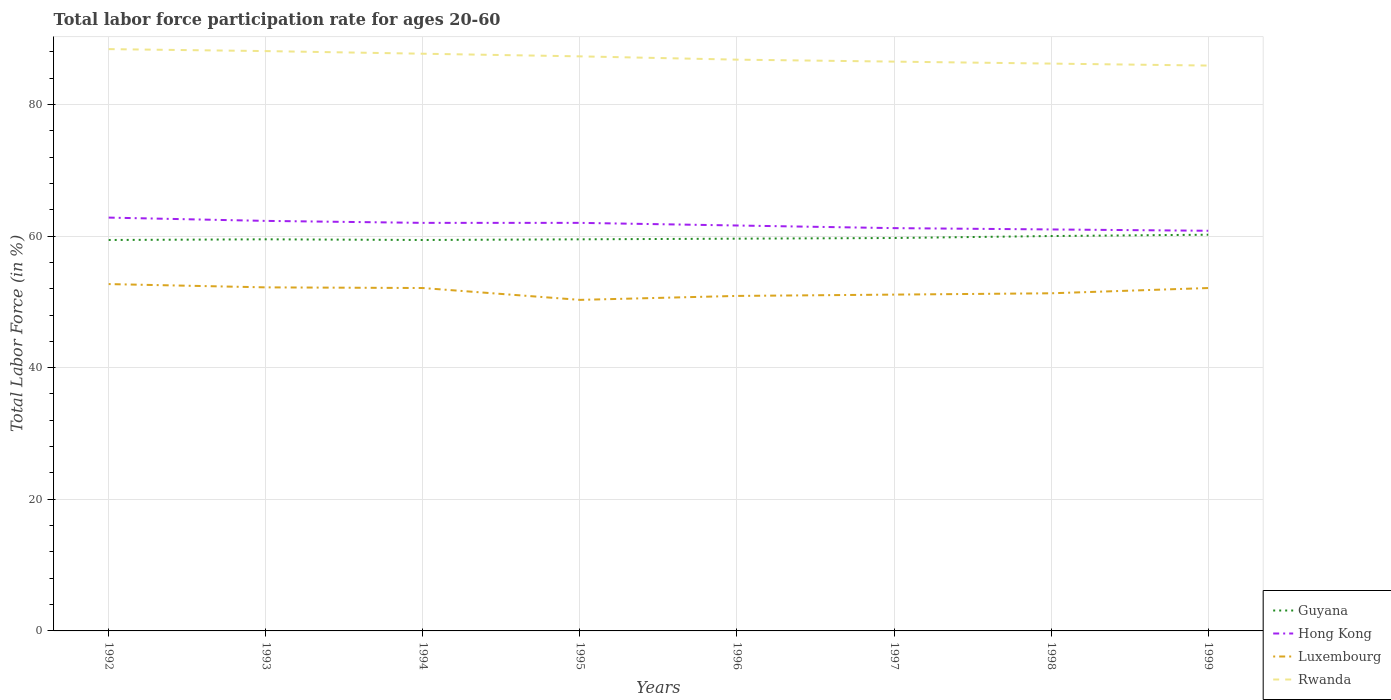How many different coloured lines are there?
Your answer should be very brief. 4. Does the line corresponding to Rwanda intersect with the line corresponding to Luxembourg?
Your response must be concise. No. Is the number of lines equal to the number of legend labels?
Give a very brief answer. Yes. Across all years, what is the maximum labor force participation rate in Luxembourg?
Offer a terse response. 50.3. In which year was the labor force participation rate in Luxembourg maximum?
Your answer should be compact. 1995. What is the total labor force participation rate in Luxembourg in the graph?
Offer a terse response. -0.2. What is the difference between the highest and the second highest labor force participation rate in Luxembourg?
Offer a terse response. 2.4. What is the difference between the highest and the lowest labor force participation rate in Luxembourg?
Ensure brevity in your answer.  4. What is the difference between two consecutive major ticks on the Y-axis?
Provide a short and direct response. 20. Does the graph contain any zero values?
Your response must be concise. No. Where does the legend appear in the graph?
Give a very brief answer. Bottom right. How many legend labels are there?
Your answer should be very brief. 4. How are the legend labels stacked?
Provide a short and direct response. Vertical. What is the title of the graph?
Provide a succinct answer. Total labor force participation rate for ages 20-60. Does "Poland" appear as one of the legend labels in the graph?
Give a very brief answer. No. What is the label or title of the X-axis?
Your response must be concise. Years. What is the Total Labor Force (in %) in Guyana in 1992?
Give a very brief answer. 59.4. What is the Total Labor Force (in %) of Hong Kong in 1992?
Provide a succinct answer. 62.8. What is the Total Labor Force (in %) in Luxembourg in 1992?
Your answer should be compact. 52.7. What is the Total Labor Force (in %) in Rwanda in 1992?
Offer a terse response. 88.4. What is the Total Labor Force (in %) in Guyana in 1993?
Keep it short and to the point. 59.5. What is the Total Labor Force (in %) in Hong Kong in 1993?
Make the answer very short. 62.3. What is the Total Labor Force (in %) in Luxembourg in 1993?
Ensure brevity in your answer.  52.2. What is the Total Labor Force (in %) of Rwanda in 1993?
Ensure brevity in your answer.  88.1. What is the Total Labor Force (in %) in Guyana in 1994?
Make the answer very short. 59.4. What is the Total Labor Force (in %) of Luxembourg in 1994?
Your answer should be compact. 52.1. What is the Total Labor Force (in %) of Rwanda in 1994?
Your answer should be very brief. 87.7. What is the Total Labor Force (in %) of Guyana in 1995?
Ensure brevity in your answer.  59.5. What is the Total Labor Force (in %) in Luxembourg in 1995?
Your answer should be very brief. 50.3. What is the Total Labor Force (in %) of Rwanda in 1995?
Offer a very short reply. 87.3. What is the Total Labor Force (in %) of Guyana in 1996?
Offer a very short reply. 59.6. What is the Total Labor Force (in %) of Hong Kong in 1996?
Offer a terse response. 61.6. What is the Total Labor Force (in %) of Luxembourg in 1996?
Ensure brevity in your answer.  50.9. What is the Total Labor Force (in %) in Rwanda in 1996?
Offer a terse response. 86.8. What is the Total Labor Force (in %) in Guyana in 1997?
Make the answer very short. 59.7. What is the Total Labor Force (in %) in Hong Kong in 1997?
Provide a succinct answer. 61.2. What is the Total Labor Force (in %) in Luxembourg in 1997?
Your answer should be compact. 51.1. What is the Total Labor Force (in %) of Rwanda in 1997?
Ensure brevity in your answer.  86.5. What is the Total Labor Force (in %) in Guyana in 1998?
Your answer should be compact. 60. What is the Total Labor Force (in %) in Luxembourg in 1998?
Provide a succinct answer. 51.3. What is the Total Labor Force (in %) of Rwanda in 1998?
Keep it short and to the point. 86.2. What is the Total Labor Force (in %) in Guyana in 1999?
Provide a short and direct response. 60.2. What is the Total Labor Force (in %) of Hong Kong in 1999?
Keep it short and to the point. 60.8. What is the Total Labor Force (in %) of Luxembourg in 1999?
Your response must be concise. 52.1. What is the Total Labor Force (in %) in Rwanda in 1999?
Give a very brief answer. 85.9. Across all years, what is the maximum Total Labor Force (in %) of Guyana?
Keep it short and to the point. 60.2. Across all years, what is the maximum Total Labor Force (in %) of Hong Kong?
Make the answer very short. 62.8. Across all years, what is the maximum Total Labor Force (in %) in Luxembourg?
Keep it short and to the point. 52.7. Across all years, what is the maximum Total Labor Force (in %) of Rwanda?
Your response must be concise. 88.4. Across all years, what is the minimum Total Labor Force (in %) of Guyana?
Your answer should be compact. 59.4. Across all years, what is the minimum Total Labor Force (in %) of Hong Kong?
Keep it short and to the point. 60.8. Across all years, what is the minimum Total Labor Force (in %) of Luxembourg?
Offer a very short reply. 50.3. Across all years, what is the minimum Total Labor Force (in %) of Rwanda?
Keep it short and to the point. 85.9. What is the total Total Labor Force (in %) of Guyana in the graph?
Offer a very short reply. 477.3. What is the total Total Labor Force (in %) of Hong Kong in the graph?
Give a very brief answer. 493.7. What is the total Total Labor Force (in %) of Luxembourg in the graph?
Offer a very short reply. 412.7. What is the total Total Labor Force (in %) of Rwanda in the graph?
Offer a very short reply. 696.9. What is the difference between the Total Labor Force (in %) in Guyana in 1992 and that in 1993?
Make the answer very short. -0.1. What is the difference between the Total Labor Force (in %) in Hong Kong in 1992 and that in 1993?
Ensure brevity in your answer.  0.5. What is the difference between the Total Labor Force (in %) of Guyana in 1992 and that in 1994?
Your response must be concise. 0. What is the difference between the Total Labor Force (in %) of Luxembourg in 1992 and that in 1994?
Offer a very short reply. 0.6. What is the difference between the Total Labor Force (in %) in Rwanda in 1992 and that in 1994?
Provide a succinct answer. 0.7. What is the difference between the Total Labor Force (in %) in Guyana in 1992 and that in 1995?
Provide a short and direct response. -0.1. What is the difference between the Total Labor Force (in %) of Hong Kong in 1992 and that in 1995?
Keep it short and to the point. 0.8. What is the difference between the Total Labor Force (in %) of Luxembourg in 1992 and that in 1995?
Provide a succinct answer. 2.4. What is the difference between the Total Labor Force (in %) in Luxembourg in 1992 and that in 1996?
Make the answer very short. 1.8. What is the difference between the Total Labor Force (in %) in Hong Kong in 1992 and that in 1997?
Make the answer very short. 1.6. What is the difference between the Total Labor Force (in %) of Luxembourg in 1992 and that in 1997?
Your answer should be very brief. 1.6. What is the difference between the Total Labor Force (in %) in Rwanda in 1992 and that in 1997?
Provide a short and direct response. 1.9. What is the difference between the Total Labor Force (in %) in Guyana in 1992 and that in 1998?
Give a very brief answer. -0.6. What is the difference between the Total Labor Force (in %) in Hong Kong in 1992 and that in 1998?
Provide a short and direct response. 1.8. What is the difference between the Total Labor Force (in %) in Luxembourg in 1992 and that in 1998?
Provide a succinct answer. 1.4. What is the difference between the Total Labor Force (in %) of Guyana in 1992 and that in 1999?
Provide a short and direct response. -0.8. What is the difference between the Total Labor Force (in %) of Luxembourg in 1992 and that in 1999?
Give a very brief answer. 0.6. What is the difference between the Total Labor Force (in %) in Luxembourg in 1993 and that in 1994?
Keep it short and to the point. 0.1. What is the difference between the Total Labor Force (in %) in Luxembourg in 1993 and that in 1995?
Provide a succinct answer. 1.9. What is the difference between the Total Labor Force (in %) in Luxembourg in 1993 and that in 1996?
Your answer should be very brief. 1.3. What is the difference between the Total Labor Force (in %) in Rwanda in 1993 and that in 1996?
Offer a very short reply. 1.3. What is the difference between the Total Labor Force (in %) of Guyana in 1993 and that in 1997?
Make the answer very short. -0.2. What is the difference between the Total Labor Force (in %) of Luxembourg in 1993 and that in 1997?
Your response must be concise. 1.1. What is the difference between the Total Labor Force (in %) in Rwanda in 1993 and that in 1997?
Offer a very short reply. 1.6. What is the difference between the Total Labor Force (in %) in Rwanda in 1993 and that in 1998?
Provide a succinct answer. 1.9. What is the difference between the Total Labor Force (in %) in Guyana in 1993 and that in 1999?
Provide a short and direct response. -0.7. What is the difference between the Total Labor Force (in %) of Luxembourg in 1993 and that in 1999?
Make the answer very short. 0.1. What is the difference between the Total Labor Force (in %) of Guyana in 1994 and that in 1995?
Offer a very short reply. -0.1. What is the difference between the Total Labor Force (in %) of Hong Kong in 1994 and that in 1995?
Ensure brevity in your answer.  0. What is the difference between the Total Labor Force (in %) in Luxembourg in 1994 and that in 1995?
Keep it short and to the point. 1.8. What is the difference between the Total Labor Force (in %) of Rwanda in 1994 and that in 1995?
Offer a very short reply. 0.4. What is the difference between the Total Labor Force (in %) in Guyana in 1994 and that in 1996?
Provide a succinct answer. -0.2. What is the difference between the Total Labor Force (in %) in Hong Kong in 1994 and that in 1996?
Offer a very short reply. 0.4. What is the difference between the Total Labor Force (in %) in Luxembourg in 1994 and that in 1996?
Ensure brevity in your answer.  1.2. What is the difference between the Total Labor Force (in %) of Rwanda in 1994 and that in 1996?
Your answer should be compact. 0.9. What is the difference between the Total Labor Force (in %) in Hong Kong in 1994 and that in 1997?
Your answer should be compact. 0.8. What is the difference between the Total Labor Force (in %) of Luxembourg in 1994 and that in 1997?
Provide a succinct answer. 1. What is the difference between the Total Labor Force (in %) of Guyana in 1994 and that in 1998?
Provide a short and direct response. -0.6. What is the difference between the Total Labor Force (in %) of Hong Kong in 1994 and that in 1998?
Ensure brevity in your answer.  1. What is the difference between the Total Labor Force (in %) in Luxembourg in 1994 and that in 1998?
Offer a terse response. 0.8. What is the difference between the Total Labor Force (in %) of Rwanda in 1994 and that in 1998?
Provide a short and direct response. 1.5. What is the difference between the Total Labor Force (in %) of Hong Kong in 1994 and that in 1999?
Provide a succinct answer. 1.2. What is the difference between the Total Labor Force (in %) in Luxembourg in 1994 and that in 1999?
Provide a short and direct response. 0. What is the difference between the Total Labor Force (in %) of Guyana in 1995 and that in 1996?
Offer a very short reply. -0.1. What is the difference between the Total Labor Force (in %) in Luxembourg in 1995 and that in 1997?
Give a very brief answer. -0.8. What is the difference between the Total Labor Force (in %) of Rwanda in 1995 and that in 1997?
Provide a succinct answer. 0.8. What is the difference between the Total Labor Force (in %) of Guyana in 1995 and that in 1998?
Give a very brief answer. -0.5. What is the difference between the Total Labor Force (in %) in Luxembourg in 1995 and that in 1998?
Provide a short and direct response. -1. What is the difference between the Total Labor Force (in %) in Guyana in 1995 and that in 1999?
Make the answer very short. -0.7. What is the difference between the Total Labor Force (in %) in Luxembourg in 1995 and that in 1999?
Give a very brief answer. -1.8. What is the difference between the Total Labor Force (in %) in Rwanda in 1995 and that in 1999?
Offer a terse response. 1.4. What is the difference between the Total Labor Force (in %) of Guyana in 1996 and that in 1997?
Offer a very short reply. -0.1. What is the difference between the Total Labor Force (in %) in Guyana in 1996 and that in 1998?
Offer a terse response. -0.4. What is the difference between the Total Labor Force (in %) in Hong Kong in 1996 and that in 1998?
Make the answer very short. 0.6. What is the difference between the Total Labor Force (in %) in Luxembourg in 1996 and that in 1998?
Provide a succinct answer. -0.4. What is the difference between the Total Labor Force (in %) in Hong Kong in 1996 and that in 1999?
Offer a terse response. 0.8. What is the difference between the Total Labor Force (in %) of Hong Kong in 1997 and that in 1998?
Give a very brief answer. 0.2. What is the difference between the Total Labor Force (in %) in Luxembourg in 1997 and that in 1998?
Your answer should be compact. -0.2. What is the difference between the Total Labor Force (in %) in Rwanda in 1997 and that in 1998?
Provide a short and direct response. 0.3. What is the difference between the Total Labor Force (in %) in Guyana in 1997 and that in 1999?
Your response must be concise. -0.5. What is the difference between the Total Labor Force (in %) of Hong Kong in 1997 and that in 1999?
Your answer should be very brief. 0.4. What is the difference between the Total Labor Force (in %) of Hong Kong in 1998 and that in 1999?
Give a very brief answer. 0.2. What is the difference between the Total Labor Force (in %) of Guyana in 1992 and the Total Labor Force (in %) of Hong Kong in 1993?
Provide a short and direct response. -2.9. What is the difference between the Total Labor Force (in %) in Guyana in 1992 and the Total Labor Force (in %) in Luxembourg in 1993?
Offer a terse response. 7.2. What is the difference between the Total Labor Force (in %) in Guyana in 1992 and the Total Labor Force (in %) in Rwanda in 1993?
Your answer should be compact. -28.7. What is the difference between the Total Labor Force (in %) of Hong Kong in 1992 and the Total Labor Force (in %) of Luxembourg in 1993?
Give a very brief answer. 10.6. What is the difference between the Total Labor Force (in %) of Hong Kong in 1992 and the Total Labor Force (in %) of Rwanda in 1993?
Your answer should be compact. -25.3. What is the difference between the Total Labor Force (in %) of Luxembourg in 1992 and the Total Labor Force (in %) of Rwanda in 1993?
Your answer should be compact. -35.4. What is the difference between the Total Labor Force (in %) of Guyana in 1992 and the Total Labor Force (in %) of Rwanda in 1994?
Give a very brief answer. -28.3. What is the difference between the Total Labor Force (in %) in Hong Kong in 1992 and the Total Labor Force (in %) in Rwanda in 1994?
Your answer should be very brief. -24.9. What is the difference between the Total Labor Force (in %) of Luxembourg in 1992 and the Total Labor Force (in %) of Rwanda in 1994?
Offer a very short reply. -35. What is the difference between the Total Labor Force (in %) of Guyana in 1992 and the Total Labor Force (in %) of Rwanda in 1995?
Your response must be concise. -27.9. What is the difference between the Total Labor Force (in %) in Hong Kong in 1992 and the Total Labor Force (in %) in Rwanda in 1995?
Provide a succinct answer. -24.5. What is the difference between the Total Labor Force (in %) in Luxembourg in 1992 and the Total Labor Force (in %) in Rwanda in 1995?
Offer a terse response. -34.6. What is the difference between the Total Labor Force (in %) of Guyana in 1992 and the Total Labor Force (in %) of Luxembourg in 1996?
Provide a short and direct response. 8.5. What is the difference between the Total Labor Force (in %) in Guyana in 1992 and the Total Labor Force (in %) in Rwanda in 1996?
Your response must be concise. -27.4. What is the difference between the Total Labor Force (in %) of Luxembourg in 1992 and the Total Labor Force (in %) of Rwanda in 1996?
Offer a terse response. -34.1. What is the difference between the Total Labor Force (in %) in Guyana in 1992 and the Total Labor Force (in %) in Rwanda in 1997?
Provide a short and direct response. -27.1. What is the difference between the Total Labor Force (in %) in Hong Kong in 1992 and the Total Labor Force (in %) in Rwanda in 1997?
Your answer should be very brief. -23.7. What is the difference between the Total Labor Force (in %) of Luxembourg in 1992 and the Total Labor Force (in %) of Rwanda in 1997?
Ensure brevity in your answer.  -33.8. What is the difference between the Total Labor Force (in %) of Guyana in 1992 and the Total Labor Force (in %) of Hong Kong in 1998?
Your response must be concise. -1.6. What is the difference between the Total Labor Force (in %) of Guyana in 1992 and the Total Labor Force (in %) of Luxembourg in 1998?
Your answer should be compact. 8.1. What is the difference between the Total Labor Force (in %) in Guyana in 1992 and the Total Labor Force (in %) in Rwanda in 1998?
Provide a short and direct response. -26.8. What is the difference between the Total Labor Force (in %) in Hong Kong in 1992 and the Total Labor Force (in %) in Luxembourg in 1998?
Give a very brief answer. 11.5. What is the difference between the Total Labor Force (in %) of Hong Kong in 1992 and the Total Labor Force (in %) of Rwanda in 1998?
Your answer should be very brief. -23.4. What is the difference between the Total Labor Force (in %) of Luxembourg in 1992 and the Total Labor Force (in %) of Rwanda in 1998?
Keep it short and to the point. -33.5. What is the difference between the Total Labor Force (in %) in Guyana in 1992 and the Total Labor Force (in %) in Luxembourg in 1999?
Offer a very short reply. 7.3. What is the difference between the Total Labor Force (in %) in Guyana in 1992 and the Total Labor Force (in %) in Rwanda in 1999?
Ensure brevity in your answer.  -26.5. What is the difference between the Total Labor Force (in %) of Hong Kong in 1992 and the Total Labor Force (in %) of Rwanda in 1999?
Keep it short and to the point. -23.1. What is the difference between the Total Labor Force (in %) in Luxembourg in 1992 and the Total Labor Force (in %) in Rwanda in 1999?
Your answer should be compact. -33.2. What is the difference between the Total Labor Force (in %) of Guyana in 1993 and the Total Labor Force (in %) of Hong Kong in 1994?
Make the answer very short. -2.5. What is the difference between the Total Labor Force (in %) of Guyana in 1993 and the Total Labor Force (in %) of Luxembourg in 1994?
Your answer should be compact. 7.4. What is the difference between the Total Labor Force (in %) of Guyana in 1993 and the Total Labor Force (in %) of Rwanda in 1994?
Give a very brief answer. -28.2. What is the difference between the Total Labor Force (in %) of Hong Kong in 1993 and the Total Labor Force (in %) of Rwanda in 1994?
Make the answer very short. -25.4. What is the difference between the Total Labor Force (in %) of Luxembourg in 1993 and the Total Labor Force (in %) of Rwanda in 1994?
Provide a short and direct response. -35.5. What is the difference between the Total Labor Force (in %) of Guyana in 1993 and the Total Labor Force (in %) of Hong Kong in 1995?
Make the answer very short. -2.5. What is the difference between the Total Labor Force (in %) in Guyana in 1993 and the Total Labor Force (in %) in Luxembourg in 1995?
Ensure brevity in your answer.  9.2. What is the difference between the Total Labor Force (in %) in Guyana in 1993 and the Total Labor Force (in %) in Rwanda in 1995?
Provide a short and direct response. -27.8. What is the difference between the Total Labor Force (in %) in Hong Kong in 1993 and the Total Labor Force (in %) in Luxembourg in 1995?
Your response must be concise. 12. What is the difference between the Total Labor Force (in %) of Hong Kong in 1993 and the Total Labor Force (in %) of Rwanda in 1995?
Ensure brevity in your answer.  -25. What is the difference between the Total Labor Force (in %) in Luxembourg in 1993 and the Total Labor Force (in %) in Rwanda in 1995?
Keep it short and to the point. -35.1. What is the difference between the Total Labor Force (in %) in Guyana in 1993 and the Total Labor Force (in %) in Rwanda in 1996?
Your answer should be very brief. -27.3. What is the difference between the Total Labor Force (in %) in Hong Kong in 1993 and the Total Labor Force (in %) in Rwanda in 1996?
Your answer should be very brief. -24.5. What is the difference between the Total Labor Force (in %) of Luxembourg in 1993 and the Total Labor Force (in %) of Rwanda in 1996?
Your answer should be compact. -34.6. What is the difference between the Total Labor Force (in %) of Guyana in 1993 and the Total Labor Force (in %) of Luxembourg in 1997?
Give a very brief answer. 8.4. What is the difference between the Total Labor Force (in %) of Hong Kong in 1993 and the Total Labor Force (in %) of Luxembourg in 1997?
Give a very brief answer. 11.2. What is the difference between the Total Labor Force (in %) in Hong Kong in 1993 and the Total Labor Force (in %) in Rwanda in 1997?
Your answer should be compact. -24.2. What is the difference between the Total Labor Force (in %) in Luxembourg in 1993 and the Total Labor Force (in %) in Rwanda in 1997?
Offer a very short reply. -34.3. What is the difference between the Total Labor Force (in %) in Guyana in 1993 and the Total Labor Force (in %) in Hong Kong in 1998?
Your answer should be compact. -1.5. What is the difference between the Total Labor Force (in %) in Guyana in 1993 and the Total Labor Force (in %) in Luxembourg in 1998?
Offer a terse response. 8.2. What is the difference between the Total Labor Force (in %) of Guyana in 1993 and the Total Labor Force (in %) of Rwanda in 1998?
Ensure brevity in your answer.  -26.7. What is the difference between the Total Labor Force (in %) in Hong Kong in 1993 and the Total Labor Force (in %) in Luxembourg in 1998?
Offer a terse response. 11. What is the difference between the Total Labor Force (in %) of Hong Kong in 1993 and the Total Labor Force (in %) of Rwanda in 1998?
Give a very brief answer. -23.9. What is the difference between the Total Labor Force (in %) in Luxembourg in 1993 and the Total Labor Force (in %) in Rwanda in 1998?
Your answer should be very brief. -34. What is the difference between the Total Labor Force (in %) of Guyana in 1993 and the Total Labor Force (in %) of Luxembourg in 1999?
Offer a very short reply. 7.4. What is the difference between the Total Labor Force (in %) of Guyana in 1993 and the Total Labor Force (in %) of Rwanda in 1999?
Your answer should be very brief. -26.4. What is the difference between the Total Labor Force (in %) in Hong Kong in 1993 and the Total Labor Force (in %) in Luxembourg in 1999?
Provide a succinct answer. 10.2. What is the difference between the Total Labor Force (in %) in Hong Kong in 1993 and the Total Labor Force (in %) in Rwanda in 1999?
Provide a succinct answer. -23.6. What is the difference between the Total Labor Force (in %) in Luxembourg in 1993 and the Total Labor Force (in %) in Rwanda in 1999?
Give a very brief answer. -33.7. What is the difference between the Total Labor Force (in %) of Guyana in 1994 and the Total Labor Force (in %) of Luxembourg in 1995?
Your answer should be very brief. 9.1. What is the difference between the Total Labor Force (in %) of Guyana in 1994 and the Total Labor Force (in %) of Rwanda in 1995?
Offer a terse response. -27.9. What is the difference between the Total Labor Force (in %) in Hong Kong in 1994 and the Total Labor Force (in %) in Rwanda in 1995?
Provide a short and direct response. -25.3. What is the difference between the Total Labor Force (in %) in Luxembourg in 1994 and the Total Labor Force (in %) in Rwanda in 1995?
Offer a very short reply. -35.2. What is the difference between the Total Labor Force (in %) in Guyana in 1994 and the Total Labor Force (in %) in Hong Kong in 1996?
Make the answer very short. -2.2. What is the difference between the Total Labor Force (in %) of Guyana in 1994 and the Total Labor Force (in %) of Rwanda in 1996?
Give a very brief answer. -27.4. What is the difference between the Total Labor Force (in %) in Hong Kong in 1994 and the Total Labor Force (in %) in Luxembourg in 1996?
Ensure brevity in your answer.  11.1. What is the difference between the Total Labor Force (in %) of Hong Kong in 1994 and the Total Labor Force (in %) of Rwanda in 1996?
Provide a succinct answer. -24.8. What is the difference between the Total Labor Force (in %) in Luxembourg in 1994 and the Total Labor Force (in %) in Rwanda in 1996?
Give a very brief answer. -34.7. What is the difference between the Total Labor Force (in %) of Guyana in 1994 and the Total Labor Force (in %) of Luxembourg in 1997?
Provide a succinct answer. 8.3. What is the difference between the Total Labor Force (in %) in Guyana in 1994 and the Total Labor Force (in %) in Rwanda in 1997?
Provide a short and direct response. -27.1. What is the difference between the Total Labor Force (in %) in Hong Kong in 1994 and the Total Labor Force (in %) in Luxembourg in 1997?
Provide a short and direct response. 10.9. What is the difference between the Total Labor Force (in %) in Hong Kong in 1994 and the Total Labor Force (in %) in Rwanda in 1997?
Make the answer very short. -24.5. What is the difference between the Total Labor Force (in %) in Luxembourg in 1994 and the Total Labor Force (in %) in Rwanda in 1997?
Give a very brief answer. -34.4. What is the difference between the Total Labor Force (in %) of Guyana in 1994 and the Total Labor Force (in %) of Hong Kong in 1998?
Provide a short and direct response. -1.6. What is the difference between the Total Labor Force (in %) in Guyana in 1994 and the Total Labor Force (in %) in Luxembourg in 1998?
Offer a terse response. 8.1. What is the difference between the Total Labor Force (in %) in Guyana in 1994 and the Total Labor Force (in %) in Rwanda in 1998?
Give a very brief answer. -26.8. What is the difference between the Total Labor Force (in %) in Hong Kong in 1994 and the Total Labor Force (in %) in Rwanda in 1998?
Your answer should be compact. -24.2. What is the difference between the Total Labor Force (in %) in Luxembourg in 1994 and the Total Labor Force (in %) in Rwanda in 1998?
Provide a short and direct response. -34.1. What is the difference between the Total Labor Force (in %) in Guyana in 1994 and the Total Labor Force (in %) in Hong Kong in 1999?
Give a very brief answer. -1.4. What is the difference between the Total Labor Force (in %) in Guyana in 1994 and the Total Labor Force (in %) in Rwanda in 1999?
Your response must be concise. -26.5. What is the difference between the Total Labor Force (in %) in Hong Kong in 1994 and the Total Labor Force (in %) in Rwanda in 1999?
Keep it short and to the point. -23.9. What is the difference between the Total Labor Force (in %) in Luxembourg in 1994 and the Total Labor Force (in %) in Rwanda in 1999?
Keep it short and to the point. -33.8. What is the difference between the Total Labor Force (in %) in Guyana in 1995 and the Total Labor Force (in %) in Hong Kong in 1996?
Make the answer very short. -2.1. What is the difference between the Total Labor Force (in %) of Guyana in 1995 and the Total Labor Force (in %) of Luxembourg in 1996?
Your answer should be very brief. 8.6. What is the difference between the Total Labor Force (in %) of Guyana in 1995 and the Total Labor Force (in %) of Rwanda in 1996?
Ensure brevity in your answer.  -27.3. What is the difference between the Total Labor Force (in %) of Hong Kong in 1995 and the Total Labor Force (in %) of Luxembourg in 1996?
Provide a short and direct response. 11.1. What is the difference between the Total Labor Force (in %) of Hong Kong in 1995 and the Total Labor Force (in %) of Rwanda in 1996?
Ensure brevity in your answer.  -24.8. What is the difference between the Total Labor Force (in %) in Luxembourg in 1995 and the Total Labor Force (in %) in Rwanda in 1996?
Keep it short and to the point. -36.5. What is the difference between the Total Labor Force (in %) of Guyana in 1995 and the Total Labor Force (in %) of Luxembourg in 1997?
Keep it short and to the point. 8.4. What is the difference between the Total Labor Force (in %) of Hong Kong in 1995 and the Total Labor Force (in %) of Luxembourg in 1997?
Provide a short and direct response. 10.9. What is the difference between the Total Labor Force (in %) in Hong Kong in 1995 and the Total Labor Force (in %) in Rwanda in 1997?
Your response must be concise. -24.5. What is the difference between the Total Labor Force (in %) of Luxembourg in 1995 and the Total Labor Force (in %) of Rwanda in 1997?
Offer a terse response. -36.2. What is the difference between the Total Labor Force (in %) of Guyana in 1995 and the Total Labor Force (in %) of Rwanda in 1998?
Offer a terse response. -26.7. What is the difference between the Total Labor Force (in %) of Hong Kong in 1995 and the Total Labor Force (in %) of Luxembourg in 1998?
Your answer should be compact. 10.7. What is the difference between the Total Labor Force (in %) of Hong Kong in 1995 and the Total Labor Force (in %) of Rwanda in 1998?
Offer a very short reply. -24.2. What is the difference between the Total Labor Force (in %) in Luxembourg in 1995 and the Total Labor Force (in %) in Rwanda in 1998?
Your answer should be compact. -35.9. What is the difference between the Total Labor Force (in %) in Guyana in 1995 and the Total Labor Force (in %) in Luxembourg in 1999?
Ensure brevity in your answer.  7.4. What is the difference between the Total Labor Force (in %) in Guyana in 1995 and the Total Labor Force (in %) in Rwanda in 1999?
Give a very brief answer. -26.4. What is the difference between the Total Labor Force (in %) in Hong Kong in 1995 and the Total Labor Force (in %) in Luxembourg in 1999?
Give a very brief answer. 9.9. What is the difference between the Total Labor Force (in %) of Hong Kong in 1995 and the Total Labor Force (in %) of Rwanda in 1999?
Give a very brief answer. -23.9. What is the difference between the Total Labor Force (in %) of Luxembourg in 1995 and the Total Labor Force (in %) of Rwanda in 1999?
Offer a very short reply. -35.6. What is the difference between the Total Labor Force (in %) in Guyana in 1996 and the Total Labor Force (in %) in Hong Kong in 1997?
Ensure brevity in your answer.  -1.6. What is the difference between the Total Labor Force (in %) of Guyana in 1996 and the Total Labor Force (in %) of Luxembourg in 1997?
Ensure brevity in your answer.  8.5. What is the difference between the Total Labor Force (in %) of Guyana in 1996 and the Total Labor Force (in %) of Rwanda in 1997?
Provide a short and direct response. -26.9. What is the difference between the Total Labor Force (in %) of Hong Kong in 1996 and the Total Labor Force (in %) of Rwanda in 1997?
Provide a short and direct response. -24.9. What is the difference between the Total Labor Force (in %) of Luxembourg in 1996 and the Total Labor Force (in %) of Rwanda in 1997?
Offer a terse response. -35.6. What is the difference between the Total Labor Force (in %) in Guyana in 1996 and the Total Labor Force (in %) in Rwanda in 1998?
Ensure brevity in your answer.  -26.6. What is the difference between the Total Labor Force (in %) of Hong Kong in 1996 and the Total Labor Force (in %) of Luxembourg in 1998?
Your response must be concise. 10.3. What is the difference between the Total Labor Force (in %) of Hong Kong in 1996 and the Total Labor Force (in %) of Rwanda in 1998?
Your answer should be compact. -24.6. What is the difference between the Total Labor Force (in %) in Luxembourg in 1996 and the Total Labor Force (in %) in Rwanda in 1998?
Your answer should be compact. -35.3. What is the difference between the Total Labor Force (in %) of Guyana in 1996 and the Total Labor Force (in %) of Rwanda in 1999?
Keep it short and to the point. -26.3. What is the difference between the Total Labor Force (in %) in Hong Kong in 1996 and the Total Labor Force (in %) in Rwanda in 1999?
Give a very brief answer. -24.3. What is the difference between the Total Labor Force (in %) of Luxembourg in 1996 and the Total Labor Force (in %) of Rwanda in 1999?
Provide a short and direct response. -35. What is the difference between the Total Labor Force (in %) of Guyana in 1997 and the Total Labor Force (in %) of Rwanda in 1998?
Give a very brief answer. -26.5. What is the difference between the Total Labor Force (in %) in Hong Kong in 1997 and the Total Labor Force (in %) in Luxembourg in 1998?
Give a very brief answer. 9.9. What is the difference between the Total Labor Force (in %) of Hong Kong in 1997 and the Total Labor Force (in %) of Rwanda in 1998?
Your response must be concise. -25. What is the difference between the Total Labor Force (in %) of Luxembourg in 1997 and the Total Labor Force (in %) of Rwanda in 1998?
Offer a terse response. -35.1. What is the difference between the Total Labor Force (in %) in Guyana in 1997 and the Total Labor Force (in %) in Hong Kong in 1999?
Provide a succinct answer. -1.1. What is the difference between the Total Labor Force (in %) of Guyana in 1997 and the Total Labor Force (in %) of Luxembourg in 1999?
Offer a very short reply. 7.6. What is the difference between the Total Labor Force (in %) in Guyana in 1997 and the Total Labor Force (in %) in Rwanda in 1999?
Give a very brief answer. -26.2. What is the difference between the Total Labor Force (in %) in Hong Kong in 1997 and the Total Labor Force (in %) in Rwanda in 1999?
Make the answer very short. -24.7. What is the difference between the Total Labor Force (in %) in Luxembourg in 1997 and the Total Labor Force (in %) in Rwanda in 1999?
Keep it short and to the point. -34.8. What is the difference between the Total Labor Force (in %) in Guyana in 1998 and the Total Labor Force (in %) in Rwanda in 1999?
Make the answer very short. -25.9. What is the difference between the Total Labor Force (in %) of Hong Kong in 1998 and the Total Labor Force (in %) of Rwanda in 1999?
Provide a short and direct response. -24.9. What is the difference between the Total Labor Force (in %) in Luxembourg in 1998 and the Total Labor Force (in %) in Rwanda in 1999?
Keep it short and to the point. -34.6. What is the average Total Labor Force (in %) of Guyana per year?
Your answer should be compact. 59.66. What is the average Total Labor Force (in %) of Hong Kong per year?
Provide a succinct answer. 61.71. What is the average Total Labor Force (in %) of Luxembourg per year?
Give a very brief answer. 51.59. What is the average Total Labor Force (in %) in Rwanda per year?
Provide a short and direct response. 87.11. In the year 1992, what is the difference between the Total Labor Force (in %) in Guyana and Total Labor Force (in %) in Luxembourg?
Keep it short and to the point. 6.7. In the year 1992, what is the difference between the Total Labor Force (in %) of Guyana and Total Labor Force (in %) of Rwanda?
Your answer should be very brief. -29. In the year 1992, what is the difference between the Total Labor Force (in %) in Hong Kong and Total Labor Force (in %) in Luxembourg?
Keep it short and to the point. 10.1. In the year 1992, what is the difference between the Total Labor Force (in %) in Hong Kong and Total Labor Force (in %) in Rwanda?
Give a very brief answer. -25.6. In the year 1992, what is the difference between the Total Labor Force (in %) in Luxembourg and Total Labor Force (in %) in Rwanda?
Your answer should be compact. -35.7. In the year 1993, what is the difference between the Total Labor Force (in %) of Guyana and Total Labor Force (in %) of Hong Kong?
Provide a short and direct response. -2.8. In the year 1993, what is the difference between the Total Labor Force (in %) of Guyana and Total Labor Force (in %) of Luxembourg?
Offer a terse response. 7.3. In the year 1993, what is the difference between the Total Labor Force (in %) in Guyana and Total Labor Force (in %) in Rwanda?
Ensure brevity in your answer.  -28.6. In the year 1993, what is the difference between the Total Labor Force (in %) of Hong Kong and Total Labor Force (in %) of Luxembourg?
Keep it short and to the point. 10.1. In the year 1993, what is the difference between the Total Labor Force (in %) of Hong Kong and Total Labor Force (in %) of Rwanda?
Your answer should be very brief. -25.8. In the year 1993, what is the difference between the Total Labor Force (in %) of Luxembourg and Total Labor Force (in %) of Rwanda?
Your answer should be compact. -35.9. In the year 1994, what is the difference between the Total Labor Force (in %) of Guyana and Total Labor Force (in %) of Hong Kong?
Make the answer very short. -2.6. In the year 1994, what is the difference between the Total Labor Force (in %) in Guyana and Total Labor Force (in %) in Rwanda?
Offer a terse response. -28.3. In the year 1994, what is the difference between the Total Labor Force (in %) in Hong Kong and Total Labor Force (in %) in Rwanda?
Your answer should be very brief. -25.7. In the year 1994, what is the difference between the Total Labor Force (in %) of Luxembourg and Total Labor Force (in %) of Rwanda?
Your answer should be very brief. -35.6. In the year 1995, what is the difference between the Total Labor Force (in %) of Guyana and Total Labor Force (in %) of Luxembourg?
Your response must be concise. 9.2. In the year 1995, what is the difference between the Total Labor Force (in %) of Guyana and Total Labor Force (in %) of Rwanda?
Provide a succinct answer. -27.8. In the year 1995, what is the difference between the Total Labor Force (in %) of Hong Kong and Total Labor Force (in %) of Rwanda?
Give a very brief answer. -25.3. In the year 1995, what is the difference between the Total Labor Force (in %) of Luxembourg and Total Labor Force (in %) of Rwanda?
Give a very brief answer. -37. In the year 1996, what is the difference between the Total Labor Force (in %) of Guyana and Total Labor Force (in %) of Hong Kong?
Give a very brief answer. -2. In the year 1996, what is the difference between the Total Labor Force (in %) in Guyana and Total Labor Force (in %) in Rwanda?
Make the answer very short. -27.2. In the year 1996, what is the difference between the Total Labor Force (in %) of Hong Kong and Total Labor Force (in %) of Rwanda?
Provide a succinct answer. -25.2. In the year 1996, what is the difference between the Total Labor Force (in %) in Luxembourg and Total Labor Force (in %) in Rwanda?
Give a very brief answer. -35.9. In the year 1997, what is the difference between the Total Labor Force (in %) of Guyana and Total Labor Force (in %) of Hong Kong?
Ensure brevity in your answer.  -1.5. In the year 1997, what is the difference between the Total Labor Force (in %) in Guyana and Total Labor Force (in %) in Rwanda?
Provide a short and direct response. -26.8. In the year 1997, what is the difference between the Total Labor Force (in %) in Hong Kong and Total Labor Force (in %) in Rwanda?
Offer a very short reply. -25.3. In the year 1997, what is the difference between the Total Labor Force (in %) in Luxembourg and Total Labor Force (in %) in Rwanda?
Provide a succinct answer. -35.4. In the year 1998, what is the difference between the Total Labor Force (in %) in Guyana and Total Labor Force (in %) in Rwanda?
Offer a terse response. -26.2. In the year 1998, what is the difference between the Total Labor Force (in %) in Hong Kong and Total Labor Force (in %) in Luxembourg?
Ensure brevity in your answer.  9.7. In the year 1998, what is the difference between the Total Labor Force (in %) in Hong Kong and Total Labor Force (in %) in Rwanda?
Provide a succinct answer. -25.2. In the year 1998, what is the difference between the Total Labor Force (in %) in Luxembourg and Total Labor Force (in %) in Rwanda?
Provide a succinct answer. -34.9. In the year 1999, what is the difference between the Total Labor Force (in %) of Guyana and Total Labor Force (in %) of Luxembourg?
Offer a terse response. 8.1. In the year 1999, what is the difference between the Total Labor Force (in %) in Guyana and Total Labor Force (in %) in Rwanda?
Your response must be concise. -25.7. In the year 1999, what is the difference between the Total Labor Force (in %) in Hong Kong and Total Labor Force (in %) in Rwanda?
Provide a short and direct response. -25.1. In the year 1999, what is the difference between the Total Labor Force (in %) in Luxembourg and Total Labor Force (in %) in Rwanda?
Give a very brief answer. -33.8. What is the ratio of the Total Labor Force (in %) in Hong Kong in 1992 to that in 1993?
Your answer should be very brief. 1.01. What is the ratio of the Total Labor Force (in %) of Luxembourg in 1992 to that in 1993?
Offer a very short reply. 1.01. What is the ratio of the Total Labor Force (in %) of Rwanda in 1992 to that in 1993?
Offer a terse response. 1. What is the ratio of the Total Labor Force (in %) of Hong Kong in 1992 to that in 1994?
Provide a succinct answer. 1.01. What is the ratio of the Total Labor Force (in %) of Luxembourg in 1992 to that in 1994?
Give a very brief answer. 1.01. What is the ratio of the Total Labor Force (in %) in Guyana in 1992 to that in 1995?
Give a very brief answer. 1. What is the ratio of the Total Labor Force (in %) in Hong Kong in 1992 to that in 1995?
Ensure brevity in your answer.  1.01. What is the ratio of the Total Labor Force (in %) in Luxembourg in 1992 to that in 1995?
Your answer should be very brief. 1.05. What is the ratio of the Total Labor Force (in %) of Rwanda in 1992 to that in 1995?
Your response must be concise. 1.01. What is the ratio of the Total Labor Force (in %) of Hong Kong in 1992 to that in 1996?
Ensure brevity in your answer.  1.02. What is the ratio of the Total Labor Force (in %) of Luxembourg in 1992 to that in 1996?
Give a very brief answer. 1.04. What is the ratio of the Total Labor Force (in %) of Rwanda in 1992 to that in 1996?
Give a very brief answer. 1.02. What is the ratio of the Total Labor Force (in %) in Guyana in 1992 to that in 1997?
Give a very brief answer. 0.99. What is the ratio of the Total Labor Force (in %) of Hong Kong in 1992 to that in 1997?
Your response must be concise. 1.03. What is the ratio of the Total Labor Force (in %) in Luxembourg in 1992 to that in 1997?
Your answer should be very brief. 1.03. What is the ratio of the Total Labor Force (in %) of Rwanda in 1992 to that in 1997?
Ensure brevity in your answer.  1.02. What is the ratio of the Total Labor Force (in %) in Guyana in 1992 to that in 1998?
Your response must be concise. 0.99. What is the ratio of the Total Labor Force (in %) of Hong Kong in 1992 to that in 1998?
Make the answer very short. 1.03. What is the ratio of the Total Labor Force (in %) in Luxembourg in 1992 to that in 1998?
Provide a succinct answer. 1.03. What is the ratio of the Total Labor Force (in %) in Rwanda in 1992 to that in 1998?
Provide a succinct answer. 1.03. What is the ratio of the Total Labor Force (in %) in Guyana in 1992 to that in 1999?
Give a very brief answer. 0.99. What is the ratio of the Total Labor Force (in %) in Hong Kong in 1992 to that in 1999?
Offer a terse response. 1.03. What is the ratio of the Total Labor Force (in %) of Luxembourg in 1992 to that in 1999?
Offer a very short reply. 1.01. What is the ratio of the Total Labor Force (in %) of Rwanda in 1992 to that in 1999?
Give a very brief answer. 1.03. What is the ratio of the Total Labor Force (in %) in Luxembourg in 1993 to that in 1994?
Ensure brevity in your answer.  1. What is the ratio of the Total Labor Force (in %) in Guyana in 1993 to that in 1995?
Keep it short and to the point. 1. What is the ratio of the Total Labor Force (in %) of Hong Kong in 1993 to that in 1995?
Provide a short and direct response. 1. What is the ratio of the Total Labor Force (in %) of Luxembourg in 1993 to that in 1995?
Provide a succinct answer. 1.04. What is the ratio of the Total Labor Force (in %) in Rwanda in 1993 to that in 1995?
Give a very brief answer. 1.01. What is the ratio of the Total Labor Force (in %) in Hong Kong in 1993 to that in 1996?
Offer a very short reply. 1.01. What is the ratio of the Total Labor Force (in %) in Luxembourg in 1993 to that in 1996?
Offer a very short reply. 1.03. What is the ratio of the Total Labor Force (in %) of Rwanda in 1993 to that in 1996?
Provide a succinct answer. 1.01. What is the ratio of the Total Labor Force (in %) of Luxembourg in 1993 to that in 1997?
Provide a short and direct response. 1.02. What is the ratio of the Total Labor Force (in %) of Rwanda in 1993 to that in 1997?
Offer a terse response. 1.02. What is the ratio of the Total Labor Force (in %) of Guyana in 1993 to that in 1998?
Your answer should be compact. 0.99. What is the ratio of the Total Labor Force (in %) of Hong Kong in 1993 to that in 1998?
Your response must be concise. 1.02. What is the ratio of the Total Labor Force (in %) in Luxembourg in 1993 to that in 1998?
Your answer should be compact. 1.02. What is the ratio of the Total Labor Force (in %) in Rwanda in 1993 to that in 1998?
Make the answer very short. 1.02. What is the ratio of the Total Labor Force (in %) in Guyana in 1993 to that in 1999?
Give a very brief answer. 0.99. What is the ratio of the Total Labor Force (in %) of Hong Kong in 1993 to that in 1999?
Offer a terse response. 1.02. What is the ratio of the Total Labor Force (in %) of Luxembourg in 1993 to that in 1999?
Provide a succinct answer. 1. What is the ratio of the Total Labor Force (in %) of Rwanda in 1993 to that in 1999?
Provide a succinct answer. 1.03. What is the ratio of the Total Labor Force (in %) of Luxembourg in 1994 to that in 1995?
Offer a terse response. 1.04. What is the ratio of the Total Labor Force (in %) of Luxembourg in 1994 to that in 1996?
Make the answer very short. 1.02. What is the ratio of the Total Labor Force (in %) in Rwanda in 1994 to that in 1996?
Give a very brief answer. 1.01. What is the ratio of the Total Labor Force (in %) of Guyana in 1994 to that in 1997?
Ensure brevity in your answer.  0.99. What is the ratio of the Total Labor Force (in %) of Hong Kong in 1994 to that in 1997?
Your answer should be compact. 1.01. What is the ratio of the Total Labor Force (in %) of Luxembourg in 1994 to that in 1997?
Offer a terse response. 1.02. What is the ratio of the Total Labor Force (in %) in Rwanda in 1994 to that in 1997?
Make the answer very short. 1.01. What is the ratio of the Total Labor Force (in %) in Guyana in 1994 to that in 1998?
Provide a short and direct response. 0.99. What is the ratio of the Total Labor Force (in %) of Hong Kong in 1994 to that in 1998?
Keep it short and to the point. 1.02. What is the ratio of the Total Labor Force (in %) of Luxembourg in 1994 to that in 1998?
Ensure brevity in your answer.  1.02. What is the ratio of the Total Labor Force (in %) in Rwanda in 1994 to that in 1998?
Your answer should be very brief. 1.02. What is the ratio of the Total Labor Force (in %) in Guyana in 1994 to that in 1999?
Keep it short and to the point. 0.99. What is the ratio of the Total Labor Force (in %) in Hong Kong in 1994 to that in 1999?
Make the answer very short. 1.02. What is the ratio of the Total Labor Force (in %) in Luxembourg in 1994 to that in 1999?
Offer a terse response. 1. What is the ratio of the Total Labor Force (in %) of Rwanda in 1994 to that in 1999?
Ensure brevity in your answer.  1.02. What is the ratio of the Total Labor Force (in %) in Guyana in 1995 to that in 1996?
Your answer should be very brief. 1. What is the ratio of the Total Labor Force (in %) in Hong Kong in 1995 to that in 1996?
Offer a terse response. 1.01. What is the ratio of the Total Labor Force (in %) of Rwanda in 1995 to that in 1996?
Keep it short and to the point. 1.01. What is the ratio of the Total Labor Force (in %) of Guyana in 1995 to that in 1997?
Make the answer very short. 1. What is the ratio of the Total Labor Force (in %) in Hong Kong in 1995 to that in 1997?
Make the answer very short. 1.01. What is the ratio of the Total Labor Force (in %) in Luxembourg in 1995 to that in 1997?
Give a very brief answer. 0.98. What is the ratio of the Total Labor Force (in %) of Rwanda in 1995 to that in 1997?
Make the answer very short. 1.01. What is the ratio of the Total Labor Force (in %) of Hong Kong in 1995 to that in 1998?
Provide a succinct answer. 1.02. What is the ratio of the Total Labor Force (in %) in Luxembourg in 1995 to that in 1998?
Your response must be concise. 0.98. What is the ratio of the Total Labor Force (in %) in Rwanda in 1995 to that in 1998?
Your answer should be very brief. 1.01. What is the ratio of the Total Labor Force (in %) in Guyana in 1995 to that in 1999?
Your answer should be compact. 0.99. What is the ratio of the Total Labor Force (in %) in Hong Kong in 1995 to that in 1999?
Your answer should be compact. 1.02. What is the ratio of the Total Labor Force (in %) of Luxembourg in 1995 to that in 1999?
Keep it short and to the point. 0.97. What is the ratio of the Total Labor Force (in %) in Rwanda in 1995 to that in 1999?
Your answer should be compact. 1.02. What is the ratio of the Total Labor Force (in %) of Guyana in 1996 to that in 1997?
Provide a short and direct response. 1. What is the ratio of the Total Labor Force (in %) of Hong Kong in 1996 to that in 1997?
Make the answer very short. 1.01. What is the ratio of the Total Labor Force (in %) in Luxembourg in 1996 to that in 1997?
Your response must be concise. 1. What is the ratio of the Total Labor Force (in %) in Hong Kong in 1996 to that in 1998?
Your answer should be very brief. 1.01. What is the ratio of the Total Labor Force (in %) in Rwanda in 1996 to that in 1998?
Make the answer very short. 1.01. What is the ratio of the Total Labor Force (in %) in Guyana in 1996 to that in 1999?
Provide a short and direct response. 0.99. What is the ratio of the Total Labor Force (in %) in Hong Kong in 1996 to that in 1999?
Provide a short and direct response. 1.01. What is the ratio of the Total Labor Force (in %) of Luxembourg in 1996 to that in 1999?
Offer a very short reply. 0.98. What is the ratio of the Total Labor Force (in %) in Rwanda in 1996 to that in 1999?
Keep it short and to the point. 1.01. What is the ratio of the Total Labor Force (in %) of Luxembourg in 1997 to that in 1998?
Your answer should be compact. 1. What is the ratio of the Total Labor Force (in %) in Hong Kong in 1997 to that in 1999?
Provide a succinct answer. 1.01. What is the ratio of the Total Labor Force (in %) of Luxembourg in 1997 to that in 1999?
Your answer should be compact. 0.98. What is the ratio of the Total Labor Force (in %) in Guyana in 1998 to that in 1999?
Offer a very short reply. 1. What is the ratio of the Total Labor Force (in %) in Luxembourg in 1998 to that in 1999?
Your answer should be very brief. 0.98. What is the ratio of the Total Labor Force (in %) in Rwanda in 1998 to that in 1999?
Your answer should be compact. 1. What is the difference between the highest and the second highest Total Labor Force (in %) in Guyana?
Ensure brevity in your answer.  0.2. What is the difference between the highest and the second highest Total Labor Force (in %) in Hong Kong?
Your response must be concise. 0.5. What is the difference between the highest and the lowest Total Labor Force (in %) of Guyana?
Give a very brief answer. 0.8. What is the difference between the highest and the lowest Total Labor Force (in %) in Luxembourg?
Offer a terse response. 2.4. 